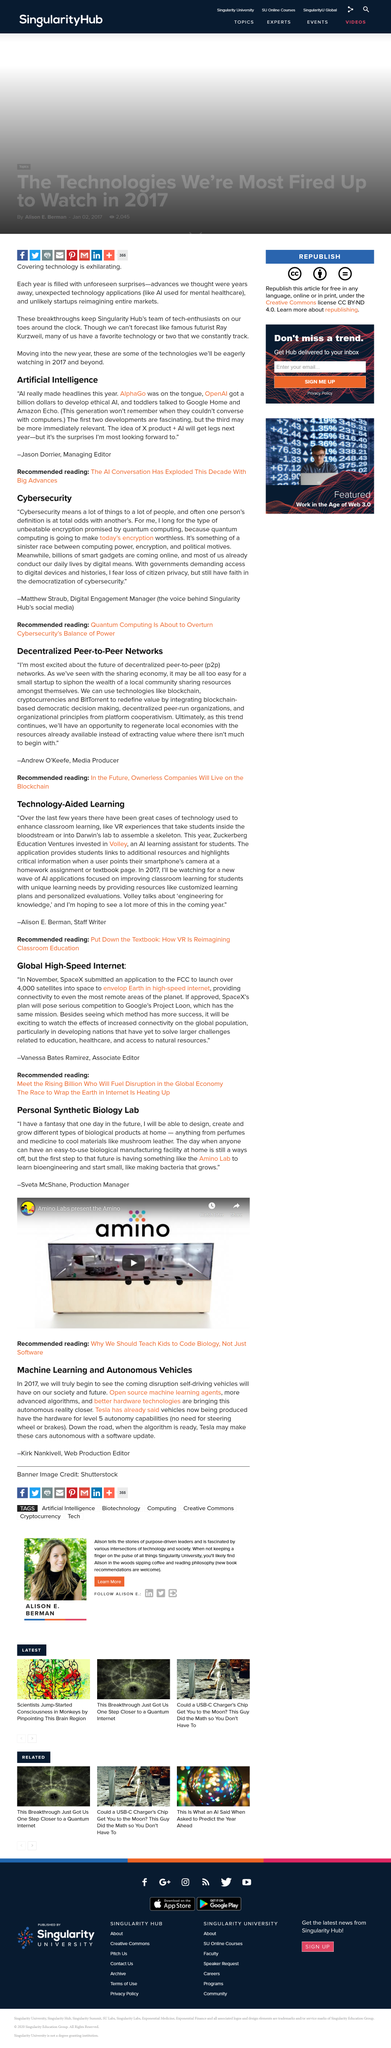Mention a couple of crucial points in this snapshot. It is easy for a small startup to siphon the wealth of a local community by sharing resources among themselves. Yes, it can be used with smartphones. OpenAI was able to develop ethical AI with approximately a billion dollars. Kirk Nankivell wrote the topic titled "Machine Learning and Autonomous Vehicles", as stated in the topic. Vanessa Bates Ramirez argues that developing nations face significant challenges, including inadequate access to education, inadequate healthcare systems, and limited access to natural resources. 